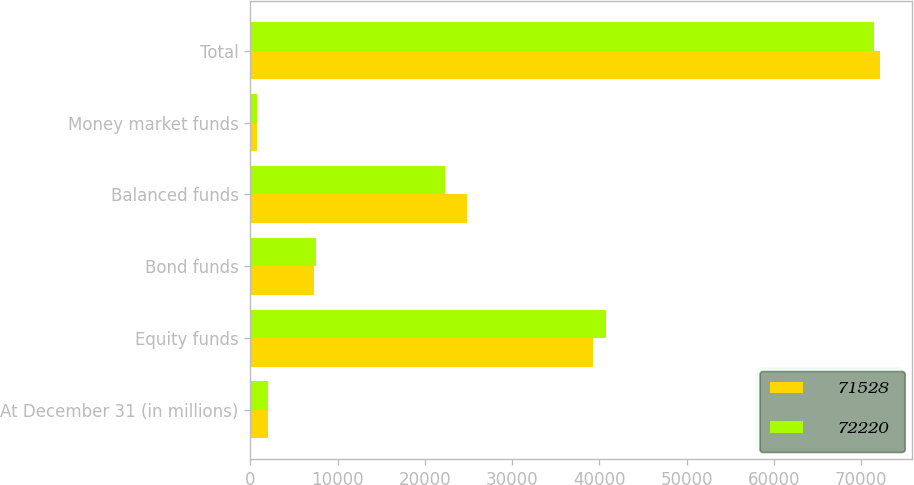Convert chart. <chart><loc_0><loc_0><loc_500><loc_500><stacked_bar_chart><ecel><fcel>At December 31 (in millions)<fcel>Equity funds<fcel>Bond funds<fcel>Balanced funds<fcel>Money market funds<fcel>Total<nl><fcel>71528<fcel>2015<fcel>39284<fcel>7261<fcel>24849<fcel>826<fcel>72220<nl><fcel>72220<fcel>2014<fcel>40811<fcel>7566<fcel>22354<fcel>797<fcel>71528<nl></chart> 